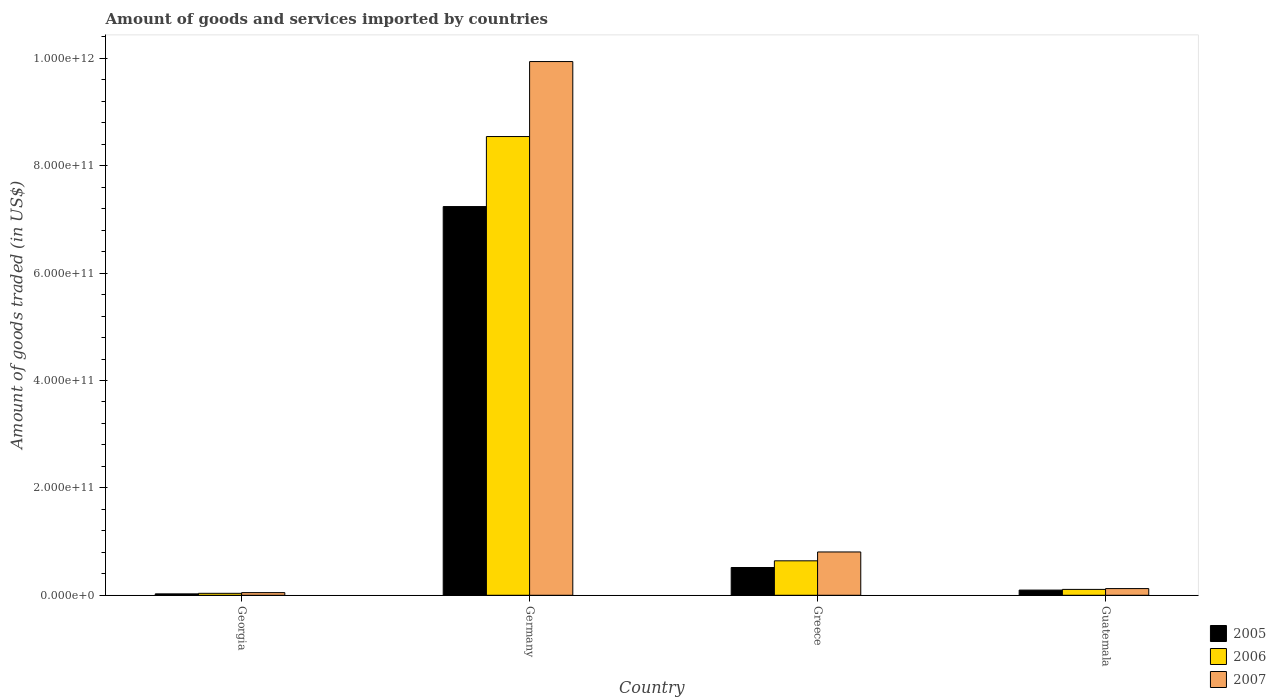Are the number of bars per tick equal to the number of legend labels?
Your answer should be compact. Yes. Are the number of bars on each tick of the X-axis equal?
Ensure brevity in your answer.  Yes. How many bars are there on the 1st tick from the left?
Your answer should be compact. 3. What is the label of the 3rd group of bars from the left?
Give a very brief answer. Greece. In how many cases, is the number of bars for a given country not equal to the number of legend labels?
Keep it short and to the point. 0. What is the total amount of goods and services imported in 2005 in Germany?
Offer a very short reply. 7.24e+11. Across all countries, what is the maximum total amount of goods and services imported in 2006?
Provide a succinct answer. 8.54e+11. Across all countries, what is the minimum total amount of goods and services imported in 2005?
Your answer should be very brief. 2.63e+09. In which country was the total amount of goods and services imported in 2006 minimum?
Keep it short and to the point. Georgia. What is the total total amount of goods and services imported in 2007 in the graph?
Offer a very short reply. 1.09e+12. What is the difference between the total amount of goods and services imported in 2007 in Greece and that in Guatemala?
Provide a short and direct response. 6.82e+1. What is the difference between the total amount of goods and services imported in 2007 in Greece and the total amount of goods and services imported in 2006 in Guatemala?
Your response must be concise. 6.97e+1. What is the average total amount of goods and services imported in 2007 per country?
Provide a succinct answer. 2.73e+11. What is the difference between the total amount of goods and services imported of/in 2005 and total amount of goods and services imported of/in 2006 in Germany?
Your response must be concise. -1.30e+11. What is the ratio of the total amount of goods and services imported in 2005 in Georgia to that in Germany?
Offer a very short reply. 0. What is the difference between the highest and the second highest total amount of goods and services imported in 2007?
Your answer should be very brief. 9.13e+11. What is the difference between the highest and the lowest total amount of goods and services imported in 2007?
Your response must be concise. 9.89e+11. In how many countries, is the total amount of goods and services imported in 2006 greater than the average total amount of goods and services imported in 2006 taken over all countries?
Provide a short and direct response. 1. Is the sum of the total amount of goods and services imported in 2005 in Germany and Greece greater than the maximum total amount of goods and services imported in 2006 across all countries?
Your response must be concise. No. How many bars are there?
Offer a terse response. 12. What is the difference between two consecutive major ticks on the Y-axis?
Keep it short and to the point. 2.00e+11. Are the values on the major ticks of Y-axis written in scientific E-notation?
Your answer should be very brief. Yes. Does the graph contain grids?
Make the answer very short. No. How are the legend labels stacked?
Ensure brevity in your answer.  Vertical. What is the title of the graph?
Provide a succinct answer. Amount of goods and services imported by countries. What is the label or title of the X-axis?
Give a very brief answer. Country. What is the label or title of the Y-axis?
Offer a terse response. Amount of goods traded (in US$). What is the Amount of goods traded (in US$) of 2005 in Georgia?
Your response must be concise. 2.63e+09. What is the Amount of goods traded (in US$) in 2006 in Georgia?
Your answer should be compact. 3.64e+09. What is the Amount of goods traded (in US$) of 2007 in Georgia?
Make the answer very short. 4.94e+09. What is the Amount of goods traded (in US$) in 2005 in Germany?
Provide a succinct answer. 7.24e+11. What is the Amount of goods traded (in US$) in 2006 in Germany?
Provide a succinct answer. 8.54e+11. What is the Amount of goods traded (in US$) of 2007 in Germany?
Offer a very short reply. 9.94e+11. What is the Amount of goods traded (in US$) of 2005 in Greece?
Ensure brevity in your answer.  5.17e+1. What is the Amount of goods traded (in US$) in 2006 in Greece?
Provide a succinct answer. 6.42e+1. What is the Amount of goods traded (in US$) in 2007 in Greece?
Your answer should be compact. 8.07e+1. What is the Amount of goods traded (in US$) in 2005 in Guatemala?
Offer a terse response. 9.65e+09. What is the Amount of goods traded (in US$) in 2006 in Guatemala?
Offer a very short reply. 1.09e+1. What is the Amount of goods traded (in US$) of 2007 in Guatemala?
Make the answer very short. 1.25e+1. Across all countries, what is the maximum Amount of goods traded (in US$) of 2005?
Give a very brief answer. 7.24e+11. Across all countries, what is the maximum Amount of goods traded (in US$) in 2006?
Make the answer very short. 8.54e+11. Across all countries, what is the maximum Amount of goods traded (in US$) in 2007?
Keep it short and to the point. 9.94e+11. Across all countries, what is the minimum Amount of goods traded (in US$) in 2005?
Your answer should be very brief. 2.63e+09. Across all countries, what is the minimum Amount of goods traded (in US$) of 2006?
Make the answer very short. 3.64e+09. Across all countries, what is the minimum Amount of goods traded (in US$) in 2007?
Give a very brief answer. 4.94e+09. What is the total Amount of goods traded (in US$) of 2005 in the graph?
Make the answer very short. 7.88e+11. What is the total Amount of goods traded (in US$) of 2006 in the graph?
Provide a succinct answer. 9.33e+11. What is the total Amount of goods traded (in US$) of 2007 in the graph?
Your answer should be very brief. 1.09e+12. What is the difference between the Amount of goods traded (in US$) in 2005 in Georgia and that in Germany?
Offer a terse response. -7.21e+11. What is the difference between the Amount of goods traded (in US$) in 2006 in Georgia and that in Germany?
Keep it short and to the point. -8.51e+11. What is the difference between the Amount of goods traded (in US$) of 2007 in Georgia and that in Germany?
Make the answer very short. -9.89e+11. What is the difference between the Amount of goods traded (in US$) of 2005 in Georgia and that in Greece?
Your answer should be very brief. -4.91e+1. What is the difference between the Amount of goods traded (in US$) of 2006 in Georgia and that in Greece?
Ensure brevity in your answer.  -6.05e+1. What is the difference between the Amount of goods traded (in US$) of 2007 in Georgia and that in Greece?
Ensure brevity in your answer.  -7.57e+1. What is the difference between the Amount of goods traded (in US$) in 2005 in Georgia and that in Guatemala?
Give a very brief answer. -7.02e+09. What is the difference between the Amount of goods traded (in US$) of 2006 in Georgia and that in Guatemala?
Give a very brief answer. -7.29e+09. What is the difference between the Amount of goods traded (in US$) of 2007 in Georgia and that in Guatemala?
Offer a very short reply. -7.53e+09. What is the difference between the Amount of goods traded (in US$) of 2005 in Germany and that in Greece?
Make the answer very short. 6.72e+11. What is the difference between the Amount of goods traded (in US$) of 2006 in Germany and that in Greece?
Ensure brevity in your answer.  7.90e+11. What is the difference between the Amount of goods traded (in US$) of 2007 in Germany and that in Greece?
Provide a short and direct response. 9.13e+11. What is the difference between the Amount of goods traded (in US$) in 2005 in Germany and that in Guatemala?
Your answer should be compact. 7.14e+11. What is the difference between the Amount of goods traded (in US$) in 2006 in Germany and that in Guatemala?
Make the answer very short. 8.44e+11. What is the difference between the Amount of goods traded (in US$) of 2007 in Germany and that in Guatemala?
Your answer should be compact. 9.82e+11. What is the difference between the Amount of goods traded (in US$) in 2005 in Greece and that in Guatemala?
Provide a succinct answer. 4.21e+1. What is the difference between the Amount of goods traded (in US$) of 2006 in Greece and that in Guatemala?
Ensure brevity in your answer.  5.32e+1. What is the difference between the Amount of goods traded (in US$) of 2007 in Greece and that in Guatemala?
Ensure brevity in your answer.  6.82e+1. What is the difference between the Amount of goods traded (in US$) in 2005 in Georgia and the Amount of goods traded (in US$) in 2006 in Germany?
Ensure brevity in your answer.  -8.52e+11. What is the difference between the Amount of goods traded (in US$) of 2005 in Georgia and the Amount of goods traded (in US$) of 2007 in Germany?
Keep it short and to the point. -9.91e+11. What is the difference between the Amount of goods traded (in US$) in 2006 in Georgia and the Amount of goods traded (in US$) in 2007 in Germany?
Offer a terse response. -9.90e+11. What is the difference between the Amount of goods traded (in US$) in 2005 in Georgia and the Amount of goods traded (in US$) in 2006 in Greece?
Offer a terse response. -6.15e+1. What is the difference between the Amount of goods traded (in US$) of 2005 in Georgia and the Amount of goods traded (in US$) of 2007 in Greece?
Provide a short and direct response. -7.80e+1. What is the difference between the Amount of goods traded (in US$) in 2006 in Georgia and the Amount of goods traded (in US$) in 2007 in Greece?
Give a very brief answer. -7.70e+1. What is the difference between the Amount of goods traded (in US$) of 2005 in Georgia and the Amount of goods traded (in US$) of 2006 in Guatemala?
Your answer should be very brief. -8.30e+09. What is the difference between the Amount of goods traded (in US$) of 2005 in Georgia and the Amount of goods traded (in US$) of 2007 in Guatemala?
Give a very brief answer. -9.84e+09. What is the difference between the Amount of goods traded (in US$) in 2006 in Georgia and the Amount of goods traded (in US$) in 2007 in Guatemala?
Offer a very short reply. -8.83e+09. What is the difference between the Amount of goods traded (in US$) of 2005 in Germany and the Amount of goods traded (in US$) of 2006 in Greece?
Provide a succinct answer. 6.60e+11. What is the difference between the Amount of goods traded (in US$) in 2005 in Germany and the Amount of goods traded (in US$) in 2007 in Greece?
Provide a short and direct response. 6.43e+11. What is the difference between the Amount of goods traded (in US$) in 2006 in Germany and the Amount of goods traded (in US$) in 2007 in Greece?
Offer a terse response. 7.74e+11. What is the difference between the Amount of goods traded (in US$) of 2005 in Germany and the Amount of goods traded (in US$) of 2006 in Guatemala?
Offer a terse response. 7.13e+11. What is the difference between the Amount of goods traded (in US$) of 2005 in Germany and the Amount of goods traded (in US$) of 2007 in Guatemala?
Offer a terse response. 7.12e+11. What is the difference between the Amount of goods traded (in US$) of 2006 in Germany and the Amount of goods traded (in US$) of 2007 in Guatemala?
Offer a very short reply. 8.42e+11. What is the difference between the Amount of goods traded (in US$) of 2005 in Greece and the Amount of goods traded (in US$) of 2006 in Guatemala?
Ensure brevity in your answer.  4.08e+1. What is the difference between the Amount of goods traded (in US$) of 2005 in Greece and the Amount of goods traded (in US$) of 2007 in Guatemala?
Your response must be concise. 3.92e+1. What is the difference between the Amount of goods traded (in US$) in 2006 in Greece and the Amount of goods traded (in US$) in 2007 in Guatemala?
Your response must be concise. 5.17e+1. What is the average Amount of goods traded (in US$) in 2005 per country?
Your answer should be compact. 1.97e+11. What is the average Amount of goods traded (in US$) of 2006 per country?
Ensure brevity in your answer.  2.33e+11. What is the average Amount of goods traded (in US$) in 2007 per country?
Keep it short and to the point. 2.73e+11. What is the difference between the Amount of goods traded (in US$) of 2005 and Amount of goods traded (in US$) of 2006 in Georgia?
Offer a terse response. -1.01e+09. What is the difference between the Amount of goods traded (in US$) in 2005 and Amount of goods traded (in US$) in 2007 in Georgia?
Ensure brevity in your answer.  -2.31e+09. What is the difference between the Amount of goods traded (in US$) in 2006 and Amount of goods traded (in US$) in 2007 in Georgia?
Offer a very short reply. -1.30e+09. What is the difference between the Amount of goods traded (in US$) of 2005 and Amount of goods traded (in US$) of 2006 in Germany?
Provide a succinct answer. -1.30e+11. What is the difference between the Amount of goods traded (in US$) of 2005 and Amount of goods traded (in US$) of 2007 in Germany?
Offer a very short reply. -2.70e+11. What is the difference between the Amount of goods traded (in US$) of 2006 and Amount of goods traded (in US$) of 2007 in Germany?
Ensure brevity in your answer.  -1.40e+11. What is the difference between the Amount of goods traded (in US$) of 2005 and Amount of goods traded (in US$) of 2006 in Greece?
Make the answer very short. -1.25e+1. What is the difference between the Amount of goods traded (in US$) of 2005 and Amount of goods traded (in US$) of 2007 in Greece?
Your response must be concise. -2.90e+1. What is the difference between the Amount of goods traded (in US$) of 2006 and Amount of goods traded (in US$) of 2007 in Greece?
Provide a succinct answer. -1.65e+1. What is the difference between the Amount of goods traded (in US$) of 2005 and Amount of goods traded (in US$) of 2006 in Guatemala?
Your answer should be compact. -1.28e+09. What is the difference between the Amount of goods traded (in US$) of 2005 and Amount of goods traded (in US$) of 2007 in Guatemala?
Make the answer very short. -2.82e+09. What is the difference between the Amount of goods traded (in US$) in 2006 and Amount of goods traded (in US$) in 2007 in Guatemala?
Your response must be concise. -1.54e+09. What is the ratio of the Amount of goods traded (in US$) in 2005 in Georgia to that in Germany?
Your response must be concise. 0. What is the ratio of the Amount of goods traded (in US$) of 2006 in Georgia to that in Germany?
Give a very brief answer. 0. What is the ratio of the Amount of goods traded (in US$) in 2007 in Georgia to that in Germany?
Your answer should be very brief. 0.01. What is the ratio of the Amount of goods traded (in US$) of 2005 in Georgia to that in Greece?
Offer a terse response. 0.05. What is the ratio of the Amount of goods traded (in US$) in 2006 in Georgia to that in Greece?
Ensure brevity in your answer.  0.06. What is the ratio of the Amount of goods traded (in US$) of 2007 in Georgia to that in Greece?
Offer a terse response. 0.06. What is the ratio of the Amount of goods traded (in US$) of 2005 in Georgia to that in Guatemala?
Offer a terse response. 0.27. What is the ratio of the Amount of goods traded (in US$) of 2006 in Georgia to that in Guatemala?
Offer a very short reply. 0.33. What is the ratio of the Amount of goods traded (in US$) of 2007 in Georgia to that in Guatemala?
Offer a very short reply. 0.4. What is the ratio of the Amount of goods traded (in US$) of 2005 in Germany to that in Greece?
Offer a very short reply. 14. What is the ratio of the Amount of goods traded (in US$) of 2006 in Germany to that in Greece?
Make the answer very short. 13.32. What is the ratio of the Amount of goods traded (in US$) of 2007 in Germany to that in Greece?
Offer a terse response. 12.32. What is the ratio of the Amount of goods traded (in US$) of 2005 in Germany to that in Guatemala?
Make the answer very short. 75.02. What is the ratio of the Amount of goods traded (in US$) in 2006 in Germany to that in Guatemala?
Offer a very short reply. 78.14. What is the ratio of the Amount of goods traded (in US$) of 2007 in Germany to that in Guatemala?
Keep it short and to the point. 79.72. What is the ratio of the Amount of goods traded (in US$) of 2005 in Greece to that in Guatemala?
Keep it short and to the point. 5.36. What is the ratio of the Amount of goods traded (in US$) in 2006 in Greece to that in Guatemala?
Make the answer very short. 5.87. What is the ratio of the Amount of goods traded (in US$) of 2007 in Greece to that in Guatemala?
Keep it short and to the point. 6.47. What is the difference between the highest and the second highest Amount of goods traded (in US$) in 2005?
Offer a terse response. 6.72e+11. What is the difference between the highest and the second highest Amount of goods traded (in US$) of 2006?
Offer a terse response. 7.90e+11. What is the difference between the highest and the second highest Amount of goods traded (in US$) of 2007?
Your answer should be compact. 9.13e+11. What is the difference between the highest and the lowest Amount of goods traded (in US$) in 2005?
Make the answer very short. 7.21e+11. What is the difference between the highest and the lowest Amount of goods traded (in US$) of 2006?
Provide a succinct answer. 8.51e+11. What is the difference between the highest and the lowest Amount of goods traded (in US$) in 2007?
Your response must be concise. 9.89e+11. 